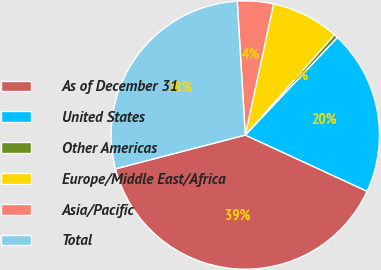<chart> <loc_0><loc_0><loc_500><loc_500><pie_chart><fcel>As of December 31<fcel>United States<fcel>Other Americas<fcel>Europe/Middle East/Africa<fcel>Asia/Pacific<fcel>Total<nl><fcel>39.07%<fcel>19.85%<fcel>0.47%<fcel>8.19%<fcel>4.33%<fcel>28.1%<nl></chart> 